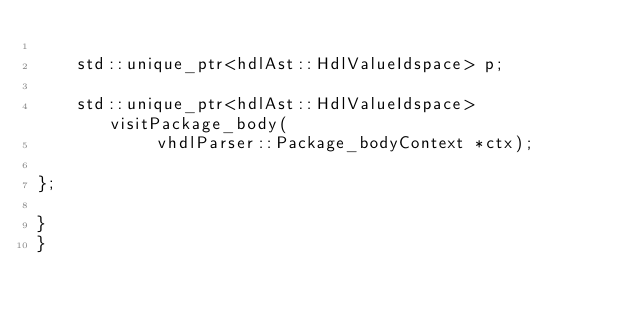Convert code to text. <code><loc_0><loc_0><loc_500><loc_500><_C_>
	std::unique_ptr<hdlAst::HdlValueIdspace> p;

	std::unique_ptr<hdlAst::HdlValueIdspace> visitPackage_body(
			vhdlParser::Package_bodyContext *ctx);

};

}
}
</code> 